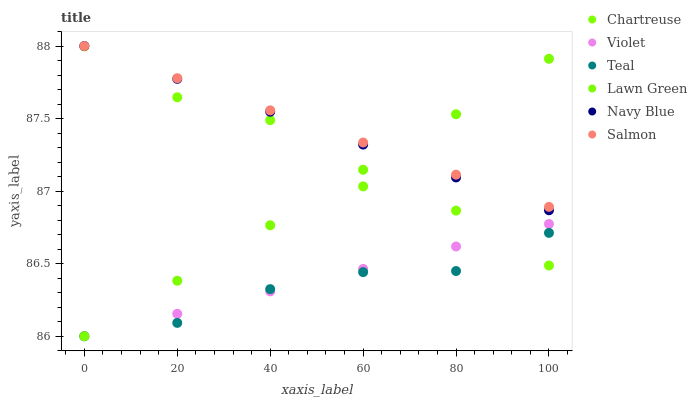Does Teal have the minimum area under the curve?
Answer yes or no. Yes. Does Salmon have the maximum area under the curve?
Answer yes or no. Yes. Does Navy Blue have the minimum area under the curve?
Answer yes or no. No. Does Navy Blue have the maximum area under the curve?
Answer yes or no. No. Is Violet the smoothest?
Answer yes or no. Yes. Is Chartreuse the roughest?
Answer yes or no. Yes. Is Navy Blue the smoothest?
Answer yes or no. No. Is Navy Blue the roughest?
Answer yes or no. No. Does Lawn Green have the lowest value?
Answer yes or no. Yes. Does Navy Blue have the lowest value?
Answer yes or no. No. Does Salmon have the highest value?
Answer yes or no. Yes. Does Chartreuse have the highest value?
Answer yes or no. No. Is Teal less than Navy Blue?
Answer yes or no. Yes. Is Navy Blue greater than Chartreuse?
Answer yes or no. Yes. Does Chartreuse intersect Lawn Green?
Answer yes or no. Yes. Is Chartreuse less than Lawn Green?
Answer yes or no. No. Is Chartreuse greater than Lawn Green?
Answer yes or no. No. Does Teal intersect Navy Blue?
Answer yes or no. No. 